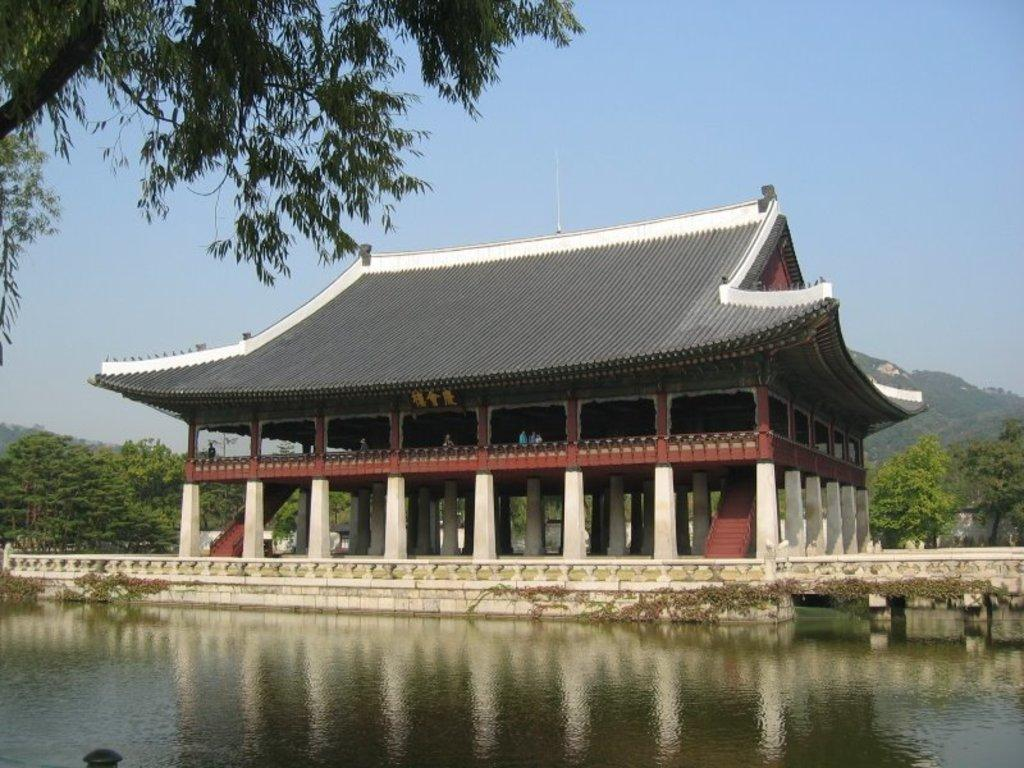What type of structure is in the image? There is a house in the image. What architectural feature can be seen on the house? The house has pillars. What is at the bottom of the image? There is water at the bottom of the image. What can be seen in the background of the image? There are trees and a mountain in the background of the image. What is visible at the top of the image? The sky is visible at the top of the image. What color is the vest worn by the bike in the image? There is no bike or vest present in the image. What type of detail can be seen on the vest of the person riding the bike in the image? There is no bike, person, or vest present in the image, so no such detail can be observed. 